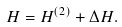<formula> <loc_0><loc_0><loc_500><loc_500>H = H ^ { ( 2 ) } + \Delta H .</formula> 